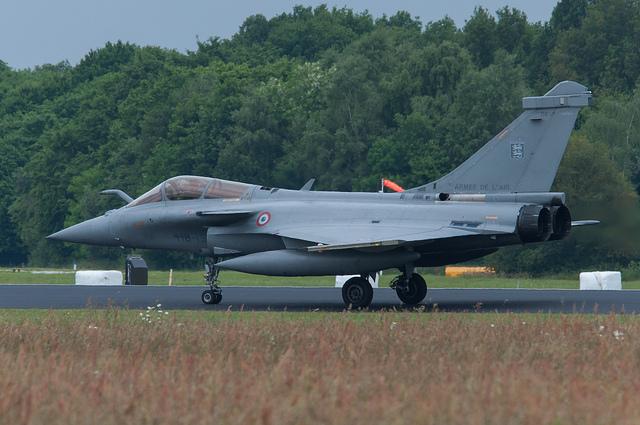Is the plane sitting on a landing strip?
Give a very brief answer. Yes. What kind of trees are in the background?
Give a very brief answer. Pine. Is the plane taking off?
Be succinct. No. Is this a modern plane?
Concise answer only. Yes. What kind of airplane is this?
Be succinct. Fighter jet. Is this a single engine plane?
Keep it brief. No. 